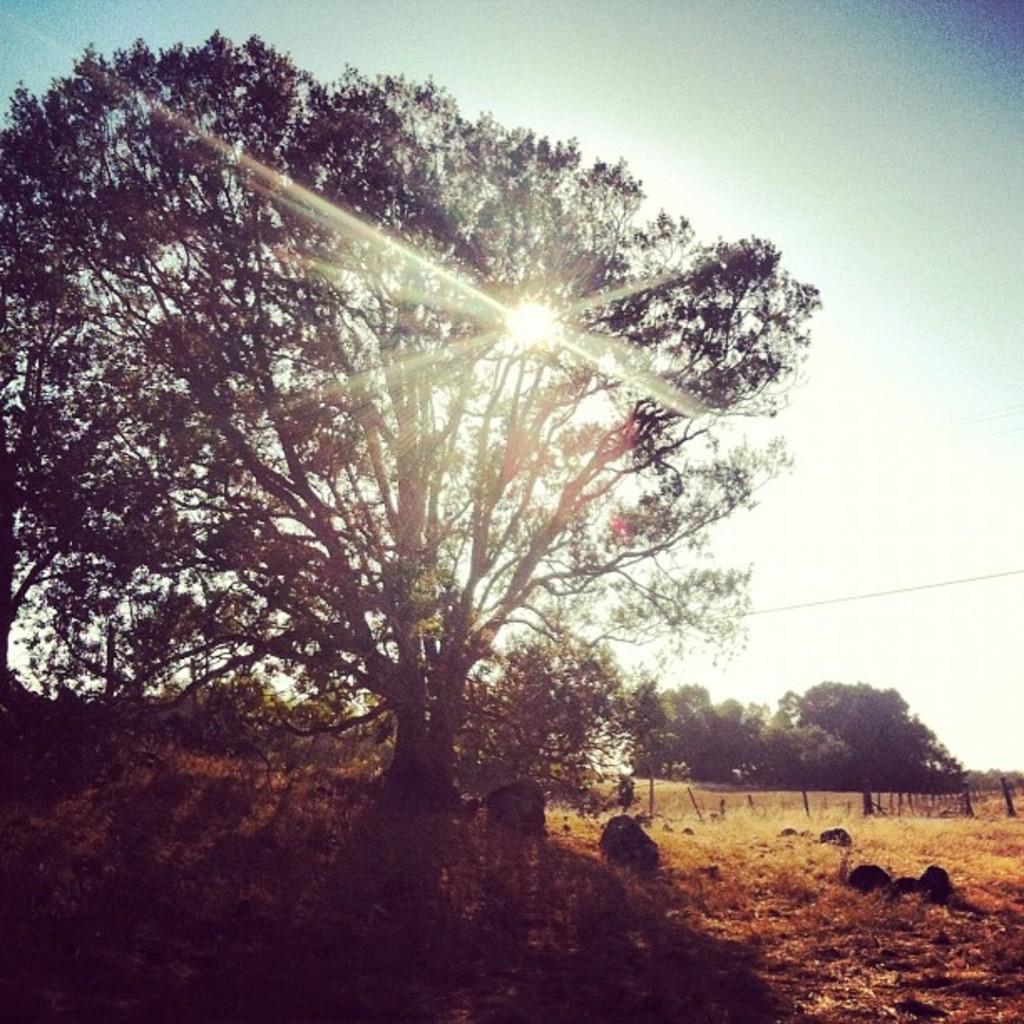How would you summarize this image in a sentence or two? In this image we can see the trees. And we can see the sun rays. And we can see the wooden fence. And we can see the stones. 